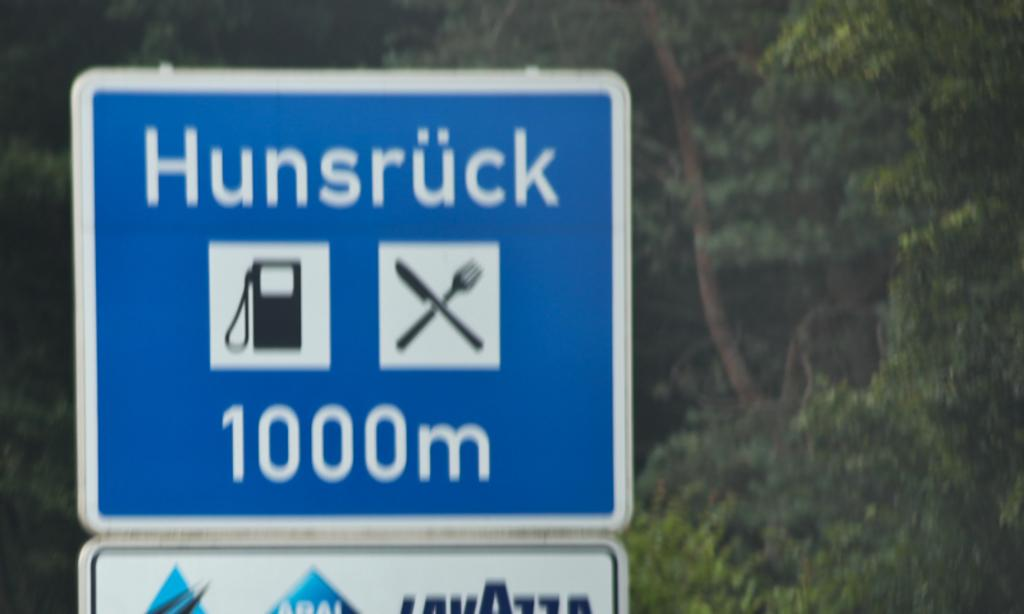<image>
Relay a brief, clear account of the picture shown. A blue sign that says Hunsruck 1000m with a picture of a gas pump and fork and knife on it. 